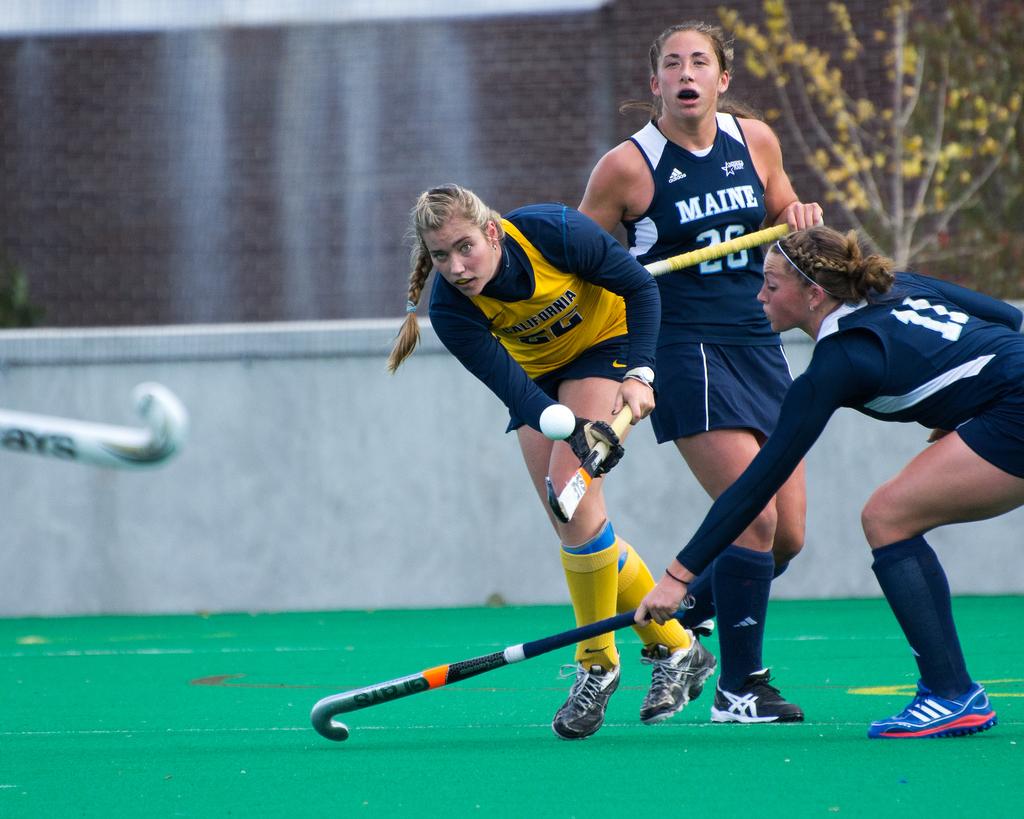What school is the blue team?
Offer a terse response. Maine. What is the player's number with a yellow stick?
Offer a very short reply. 26. 